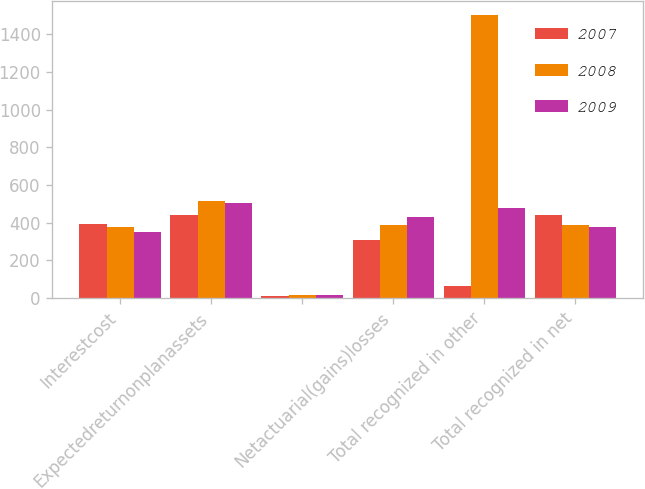<chart> <loc_0><loc_0><loc_500><loc_500><stacked_bar_chart><ecel><fcel>Interestcost<fcel>Expectedreturnonplanassets<fcel>Unnamed: 3<fcel>Netactuarial(gains)losses<fcel>Total recognized in other<fcel>Total recognized in net<nl><fcel>2007<fcel>395<fcel>439<fcel>10<fcel>310<fcel>63<fcel>443<nl><fcel>2008<fcel>379<fcel>517<fcel>15<fcel>387<fcel>1503<fcel>387<nl><fcel>2009<fcel>351<fcel>505<fcel>17<fcel>432<fcel>477<fcel>379<nl></chart> 